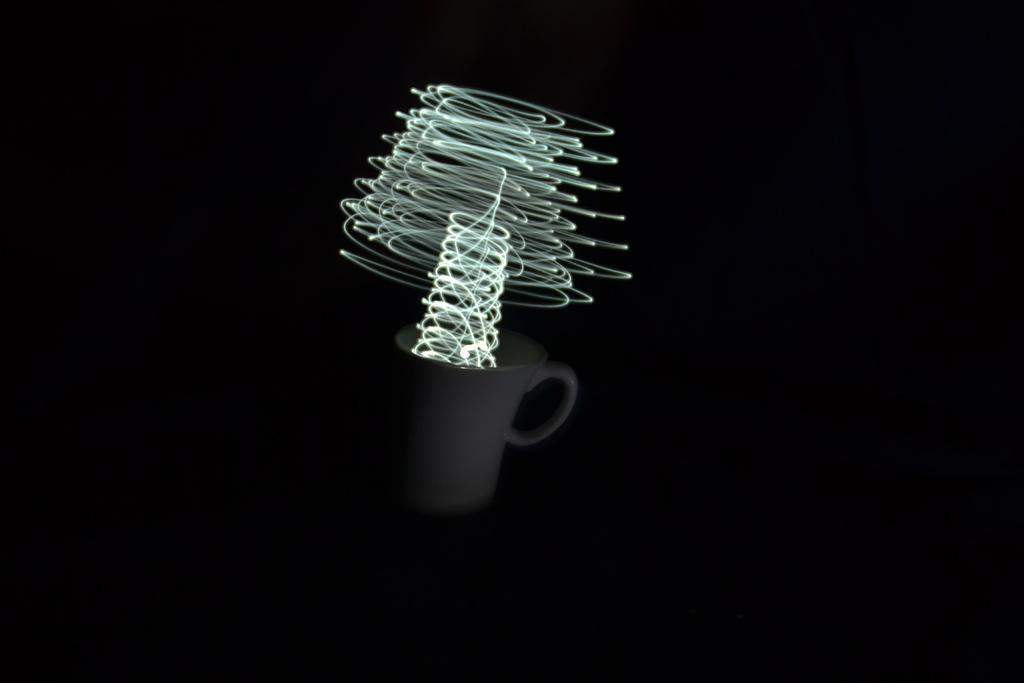Can you describe this image briefly? In this picture I can see there is a coffee mug and there are lights and the backdrop of the dark. 